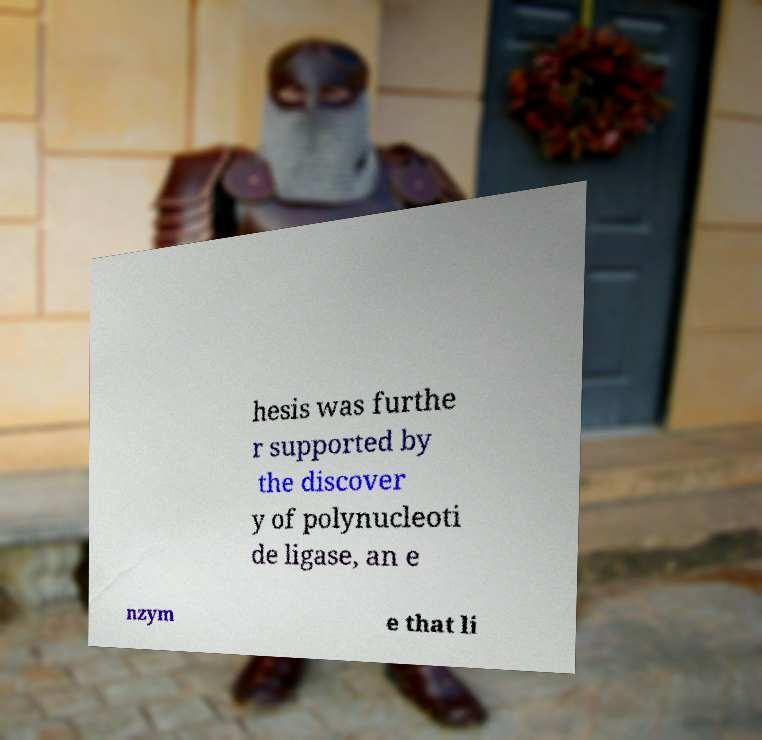What messages or text are displayed in this image? I need them in a readable, typed format. hesis was furthe r supported by the discover y of polynucleoti de ligase, an e nzym e that li 